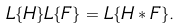<formula> <loc_0><loc_0><loc_500><loc_500>L \{ H \} L \{ F \} = L \{ H * F \} .</formula> 